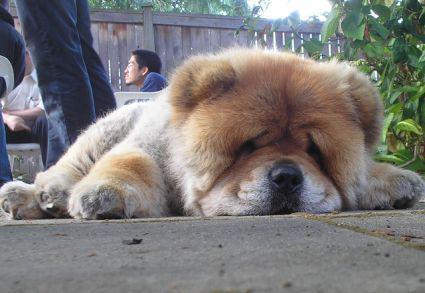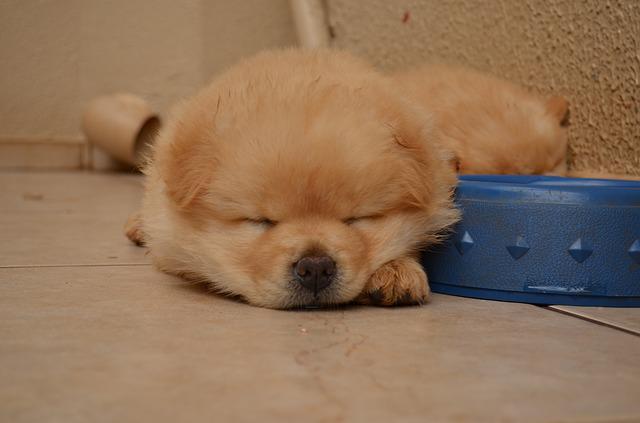The first image is the image on the left, the second image is the image on the right. Analyze the images presented: Is the assertion "There is a toy visible in one of the images." valid? Answer yes or no. No. 